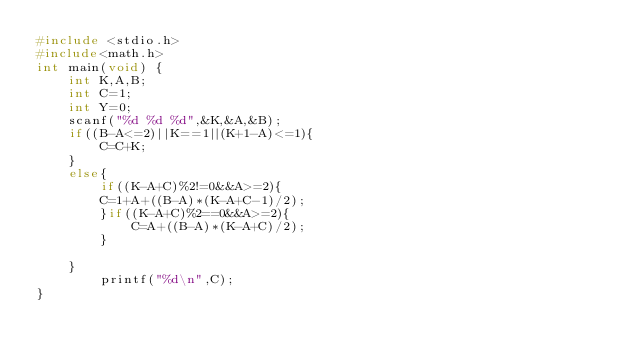Convert code to text. <code><loc_0><loc_0><loc_500><loc_500><_C_>#include <stdio.h>
#include<math.h>
int main(void) {
    int K,A,B;
    int C=1;
    int Y=0;
    scanf("%d %d %d",&K,&A,&B);
    if((B-A<=2)||K==1||(K+1-A)<=1){
    	C=C+K;
    }
    else{
    	if((K-A+C)%2!=0&&A>=2){
    	C=1+A+((B-A)*(K-A+C-1)/2);
    	}if((K-A+C)%2==0&&A>=2){
    		C=A+((B-A)*(K-A+C)/2);
    	}
    
    }
    	printf("%d\n",C);
}</code> 